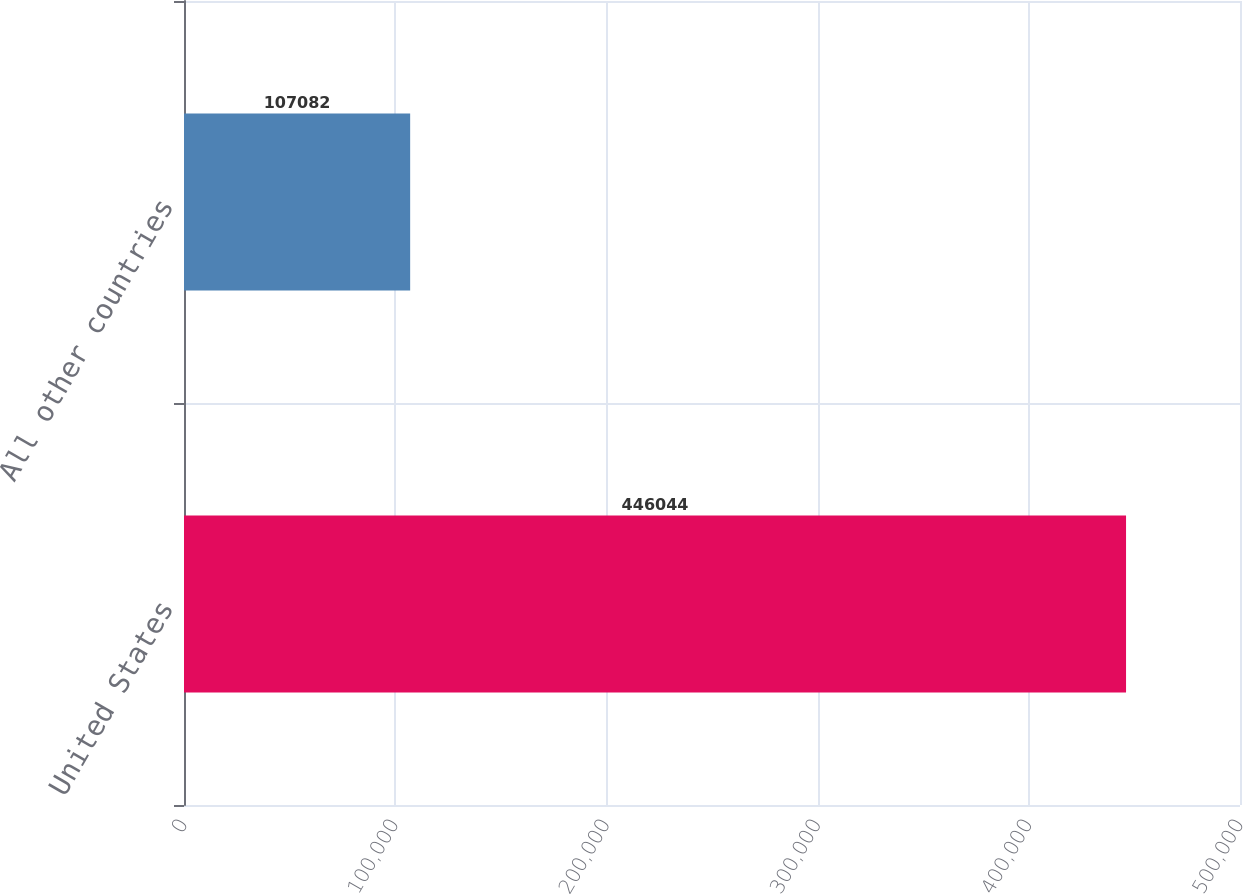Convert chart to OTSL. <chart><loc_0><loc_0><loc_500><loc_500><bar_chart><fcel>United States<fcel>All other countries<nl><fcel>446044<fcel>107082<nl></chart> 